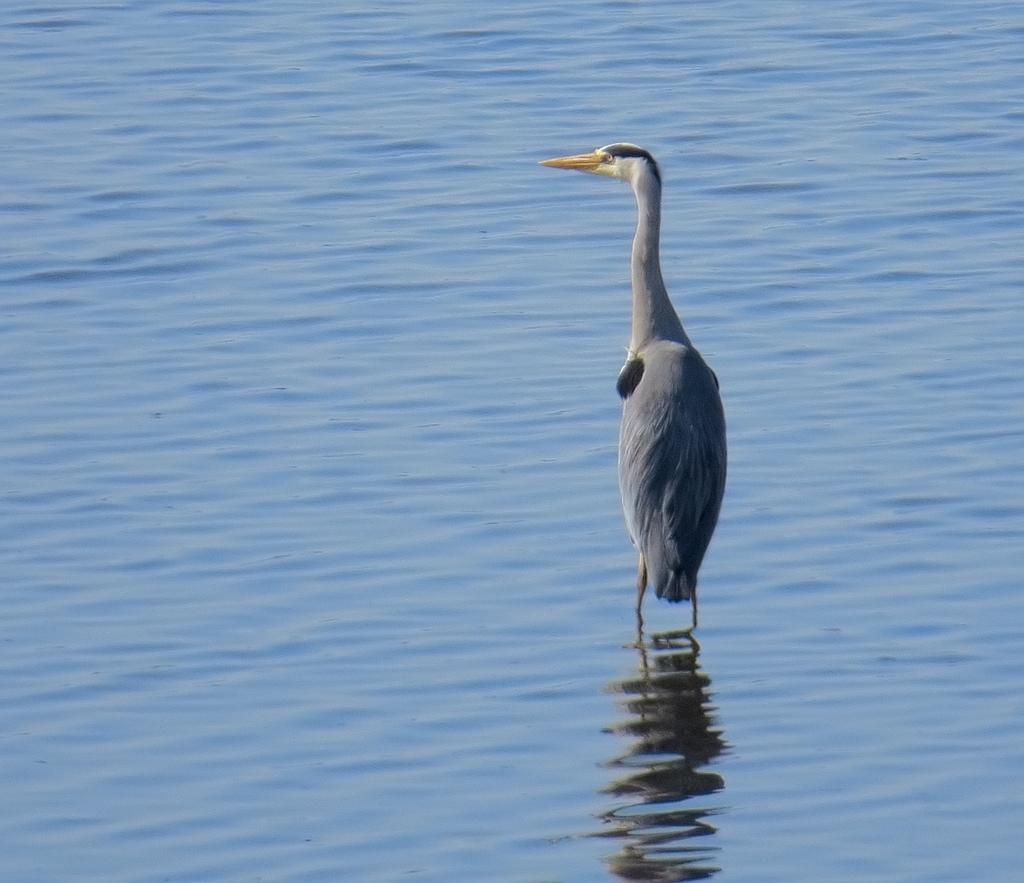What is the main feature of the image? There is a water body in the image. What can be seen in the center of the image? There is a crane in the center of the image. What type of hair can be seen on the crane in the image? There is no hair present on the crane in the image. Is there an airplane flying above the water body in the image? The provided facts do not mention an airplane, so we cannot determine if there is one in the image. What type of pail is being used by the crane in the image? There is no pail present in the image. 